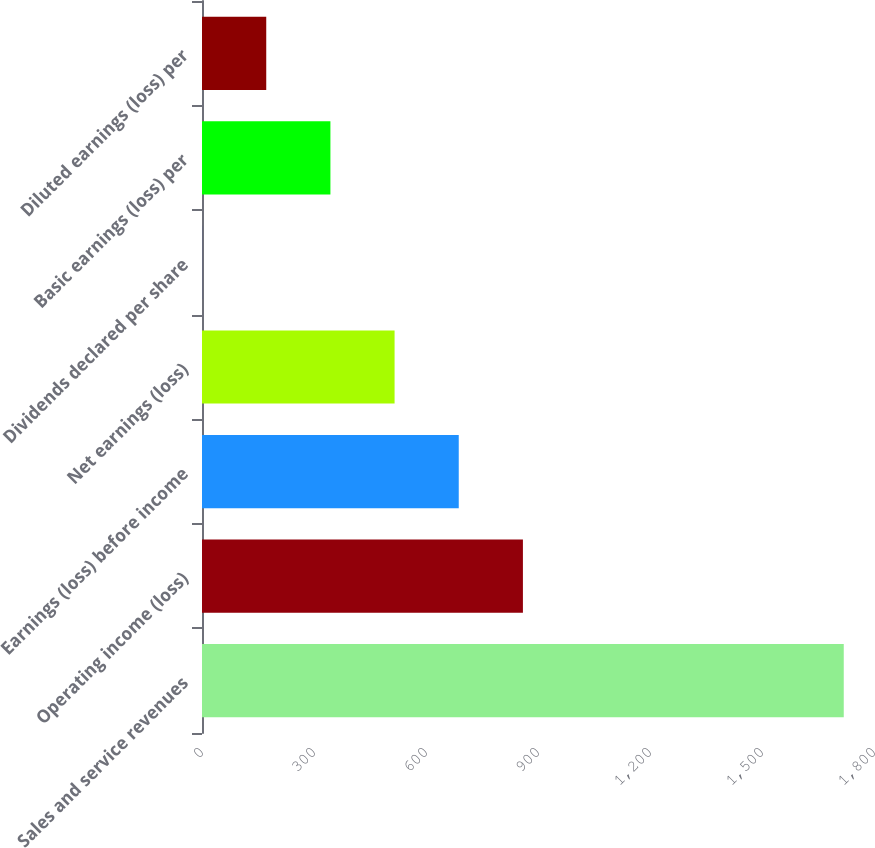<chart> <loc_0><loc_0><loc_500><loc_500><bar_chart><fcel>Sales and service revenues<fcel>Operating income (loss)<fcel>Earnings (loss) before income<fcel>Net earnings (loss)<fcel>Dividends declared per share<fcel>Basic earnings (loss) per<fcel>Diluted earnings (loss) per<nl><fcel>1719<fcel>859.6<fcel>687.72<fcel>515.84<fcel>0.2<fcel>343.96<fcel>172.08<nl></chart> 